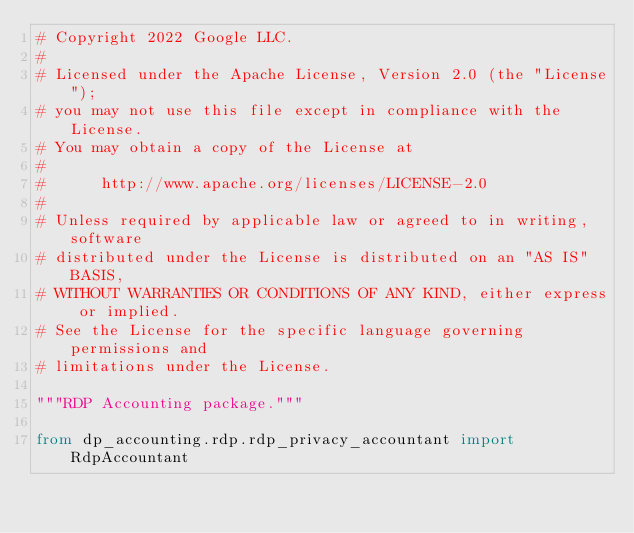Convert code to text. <code><loc_0><loc_0><loc_500><loc_500><_Python_># Copyright 2022 Google LLC.
#
# Licensed under the Apache License, Version 2.0 (the "License");
# you may not use this file except in compliance with the License.
# You may obtain a copy of the License at
#
#      http://www.apache.org/licenses/LICENSE-2.0
#
# Unless required by applicable law or agreed to in writing, software
# distributed under the License is distributed on an "AS IS" BASIS,
# WITHOUT WARRANTIES OR CONDITIONS OF ANY KIND, either express or implied.
# See the License for the specific language governing permissions and
# limitations under the License.

"""RDP Accounting package."""

from dp_accounting.rdp.rdp_privacy_accountant import RdpAccountant
</code> 